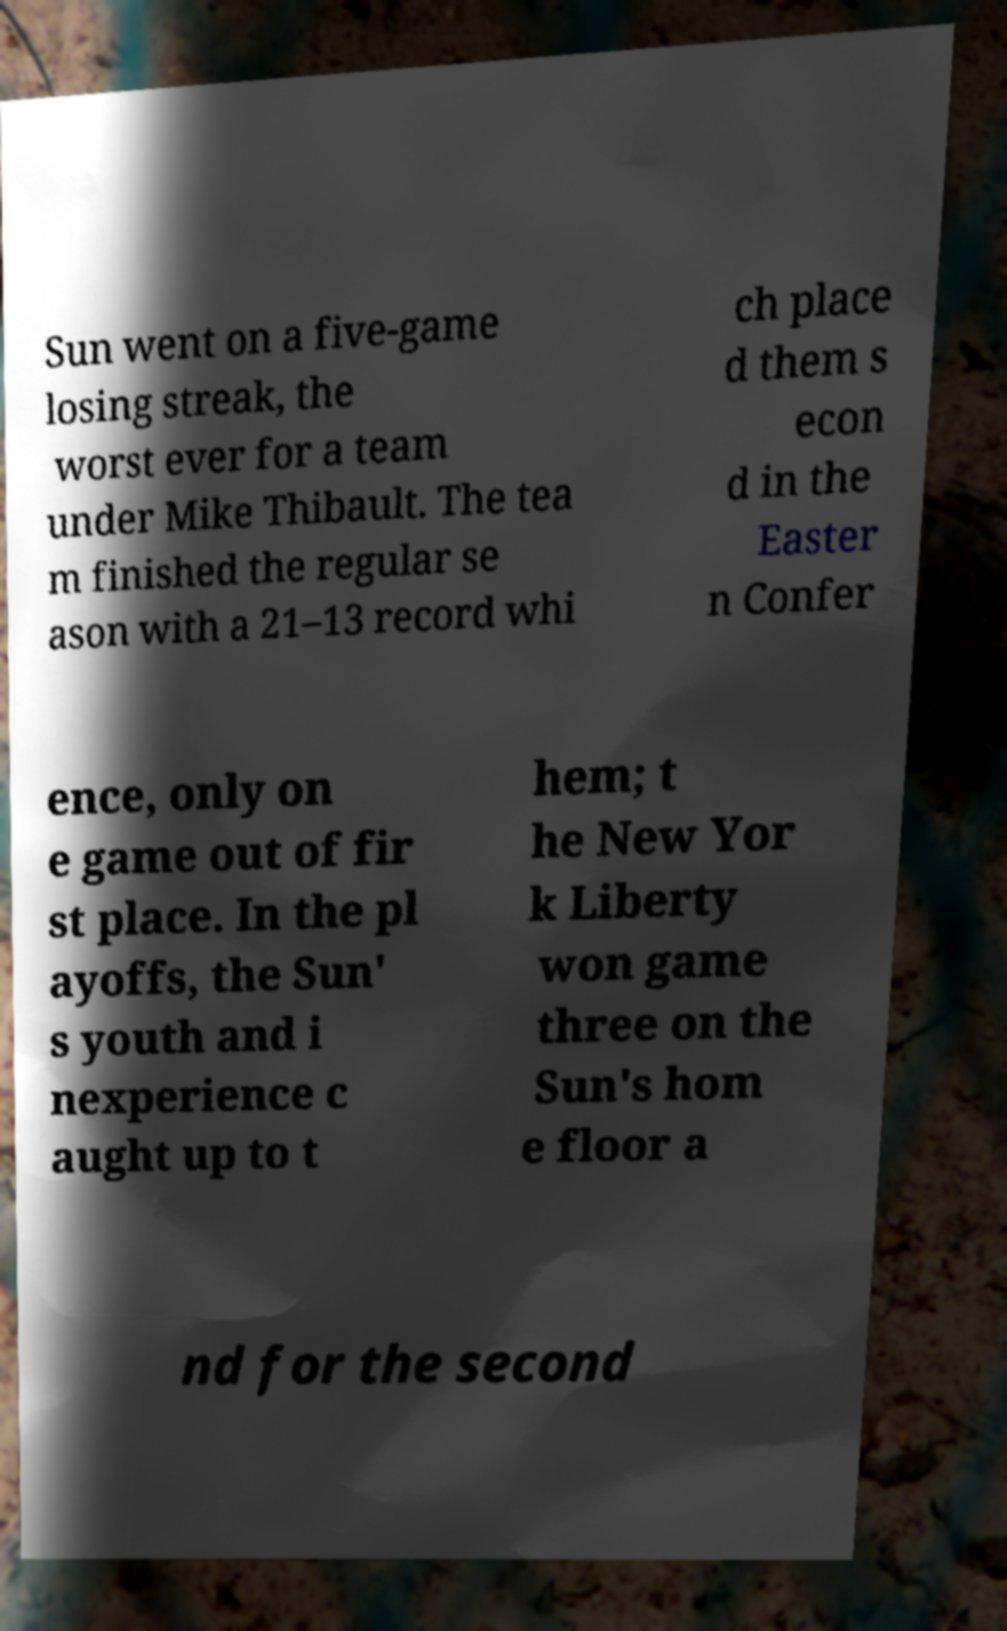Please identify and transcribe the text found in this image. Sun went on a five-game losing streak, the worst ever for a team under Mike Thibault. The tea m finished the regular se ason with a 21–13 record whi ch place d them s econ d in the Easter n Confer ence, only on e game out of fir st place. In the pl ayoffs, the Sun' s youth and i nexperience c aught up to t hem; t he New Yor k Liberty won game three on the Sun's hom e floor a nd for the second 